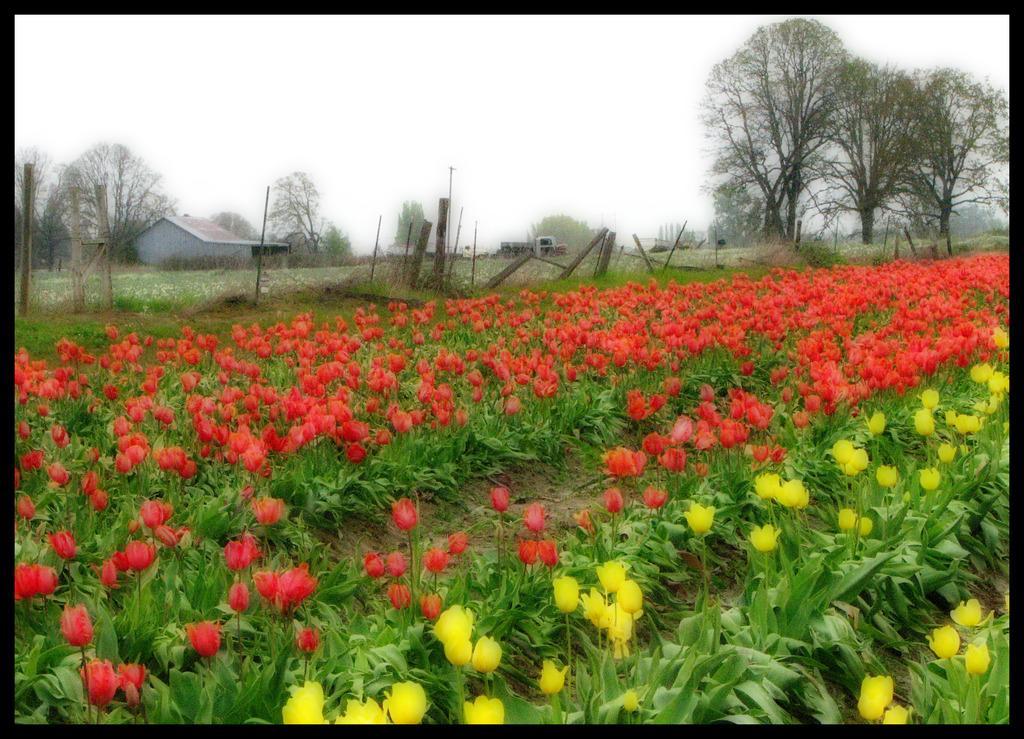Can you describe this image briefly? In the image there are red and yellow tulips flower plants all over the land and in the background there is a home with trees on either side of it and above its sky. 